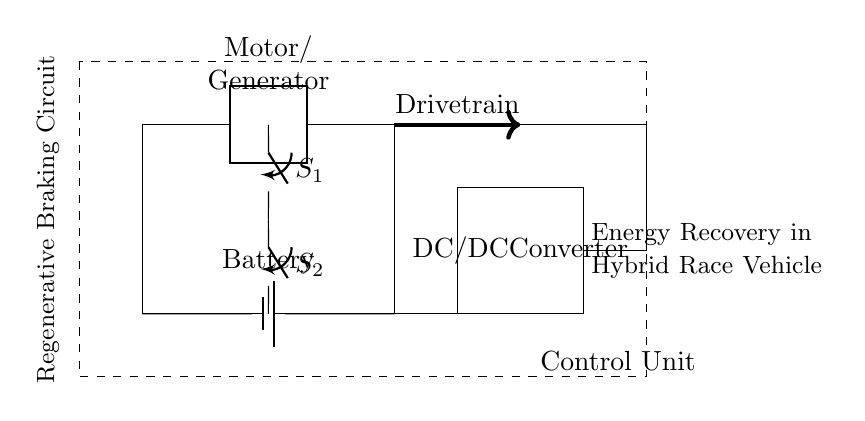What is the main component for energy recovery? The main component for energy recovery is the Motor/Generator. It is responsible for converting mechanical energy into electrical energy during regenerative braking.
Answer: Motor/Generator What does the control unit encompass? The control unit is a dashed rectangle that encapsulates various control mechanisms for the circuit, coordinating the operation of other components like the switches and the Motor/Generator.
Answer: Control Unit How many closing switches are there in the circuit? There are two closing switches labeled S1 and S2 located in series, allowing control of the circuit flow.
Answer: Two What is the function of the DC/DC converter? The DC/DC converter's function is to manage voltage levels between the battery and other circuit components, ensuring efficient energy transfer and regulation within the energy recovery system.
Answer: DC/DC Converter Why is the drivetrain indicated in the circuit? The drivetrain is indicated to show its role in mechanically connecting the Motor/Generator to the vehicle's wheels, enabling the conversion of kinetic energy into electrical energy during braking, which is a key aspect of regenerative braking.
Answer: Drivetrain Where does the battery connect in the circuit? The battery connects at the lower section of the circuit, providing the stored energy that can be replenished by the Motor/Generator during regenerative braking.
Answer: Battery 